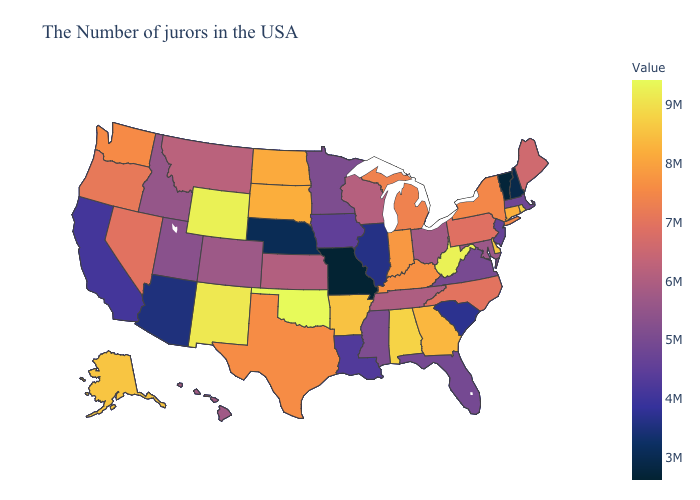Does Virginia have the lowest value in the USA?
Quick response, please. No. Does Oklahoma have the highest value in the USA?
Quick response, please. Yes. Which states have the highest value in the USA?
Answer briefly. Oklahoma. Which states have the lowest value in the USA?
Short answer required. Missouri. Among the states that border California , which have the highest value?
Give a very brief answer. Oregon. 